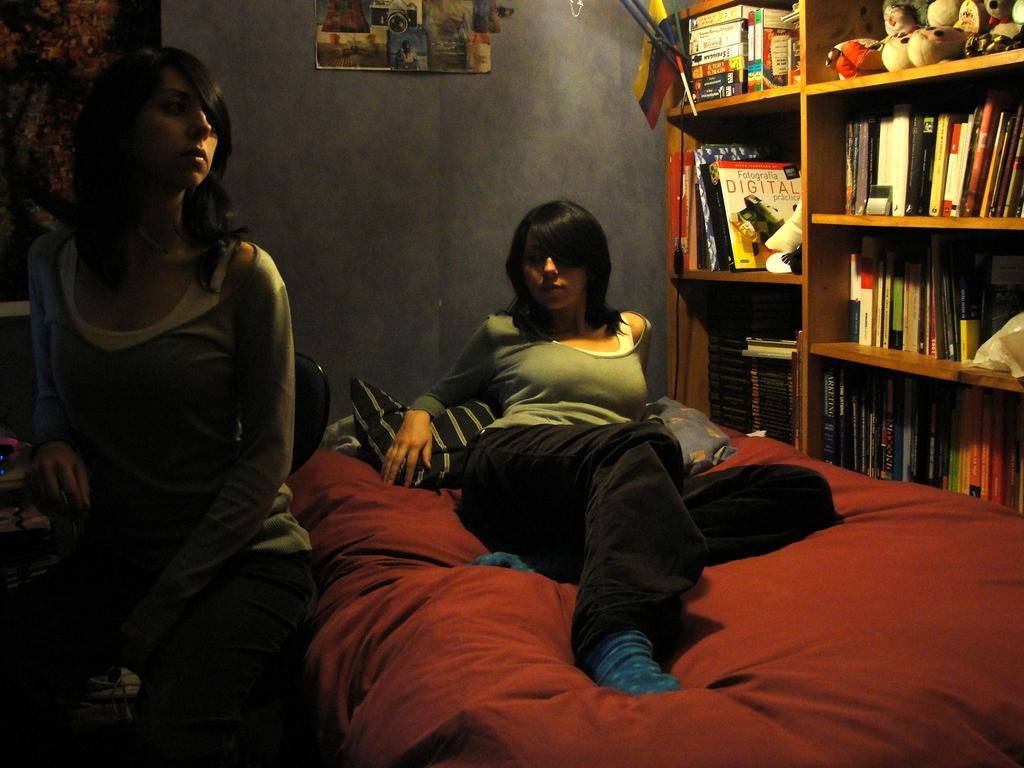What is the position of the woman in the image? There is a woman laying on the bed and another woman seated on a chair. What can be seen on the bookshelf in the image? There are books in the bookshelf. What is on the wall in the image? There is a poster on the wall. What type of furniture is visible in the image? There is a bed and a chair visible in the image. What type of accessory can be seen in the image? There are pillows visible in the image. What type of wilderness can be seen through the window in the image? There is no window or wilderness visible in the image. What is the name of the donkey that belongs to the woman seated on the chair? There is no donkey present in the image. 